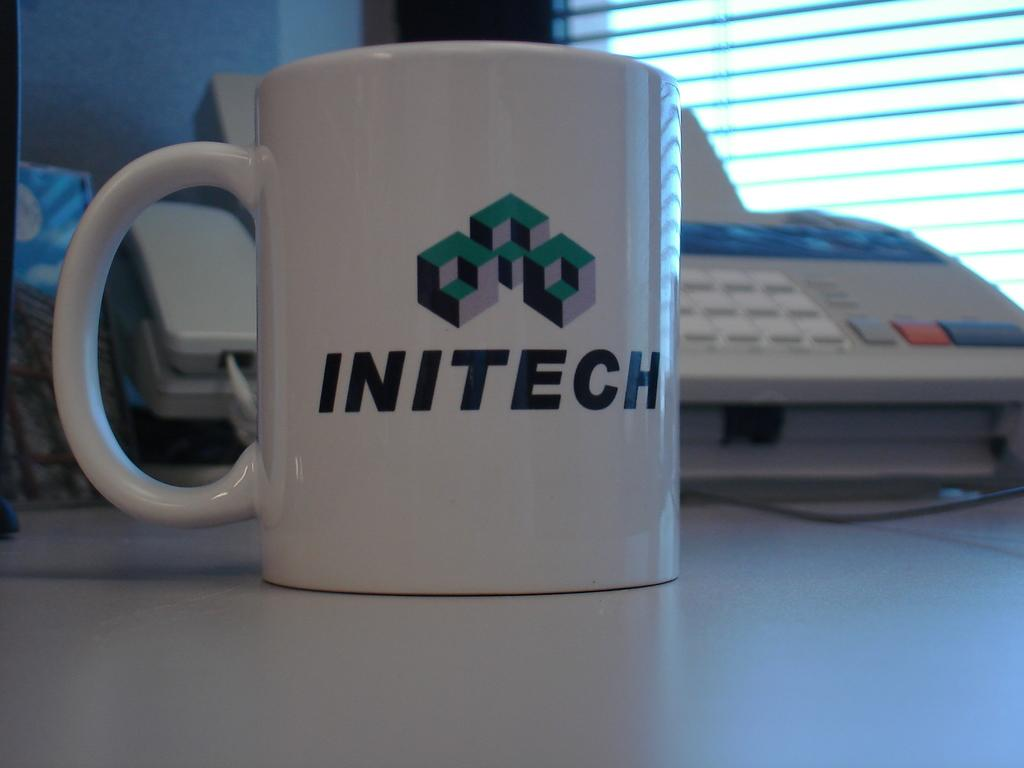What type of furniture is present in the image? There is a table in the image. What electronic device can be seen in the image? There is a keyboard in the image. What type of container is visible in the image? There is a cup in the image. What architectural feature is present in the image? There is a window in the image. What type of pump is visible in the image? There is no pump present in the image. What type of trees can be seen through the window in the image? There is no mention of trees or a window view in the image. 